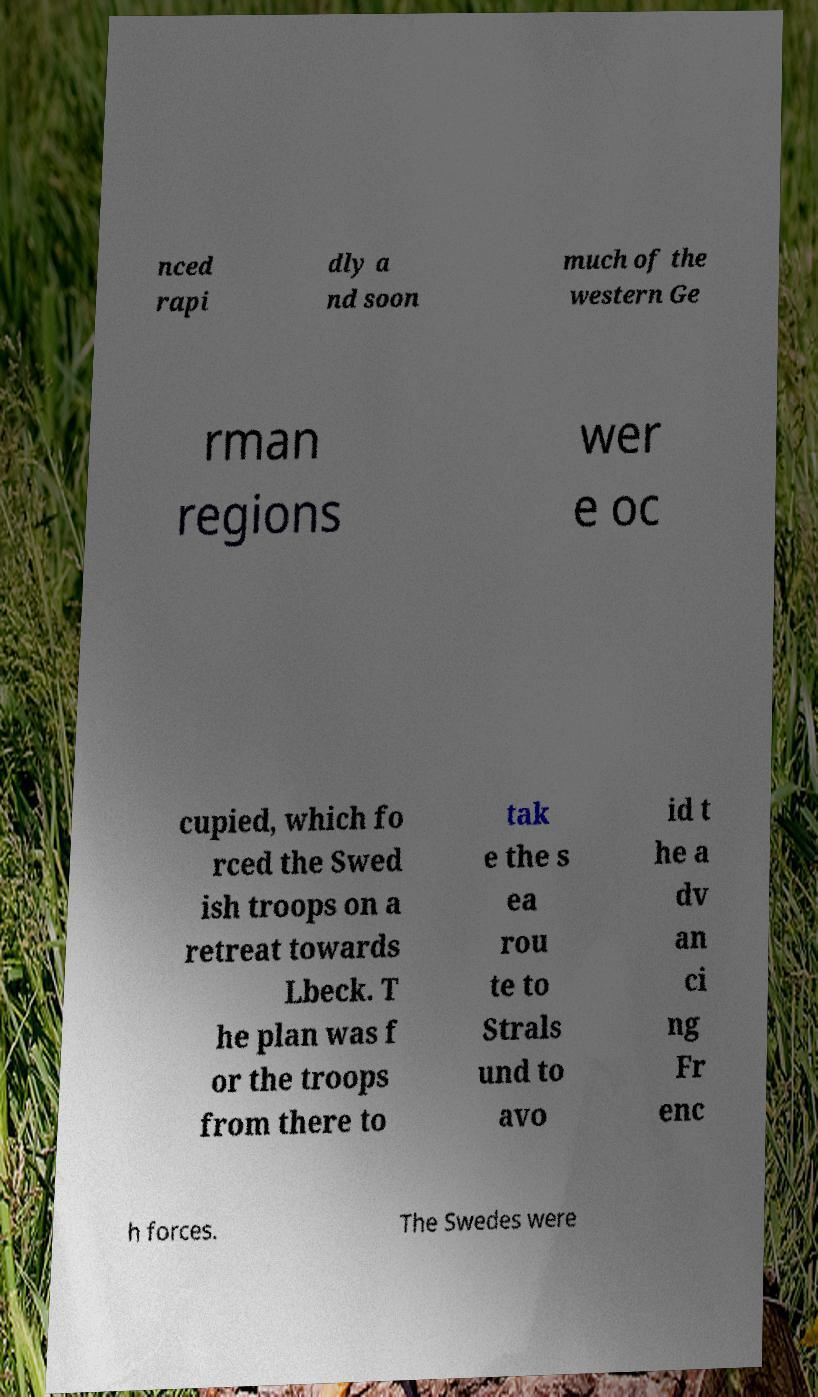Can you read and provide the text displayed in the image?This photo seems to have some interesting text. Can you extract and type it out for me? nced rapi dly a nd soon much of the western Ge rman regions wer e oc cupied, which fo rced the Swed ish troops on a retreat towards Lbeck. T he plan was f or the troops from there to tak e the s ea rou te to Strals und to avo id t he a dv an ci ng Fr enc h forces. The Swedes were 